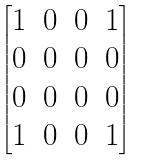<formula> <loc_0><loc_0><loc_500><loc_500>\begin{bmatrix} 1 & 0 & 0 & 1 \\ 0 & 0 & 0 & 0 \\ 0 & 0 & 0 & 0 \\ 1 & 0 & 0 & 1 \end{bmatrix}</formula> 